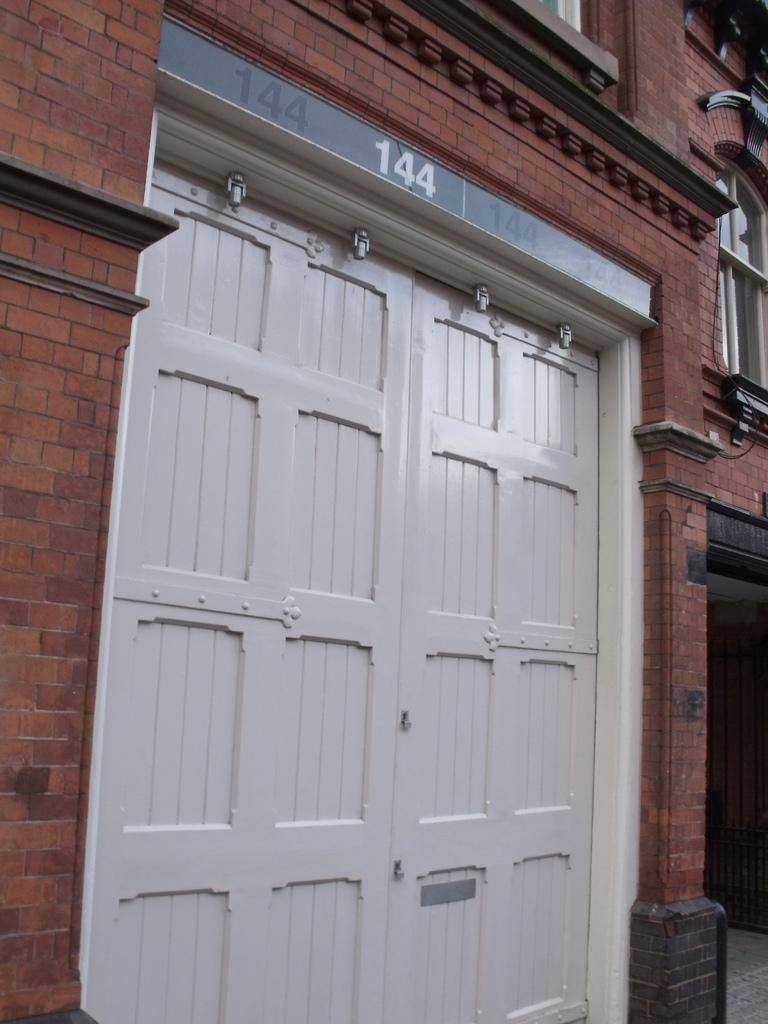Could you give a brief overview of what you see in this image? In this image, we can see a building with doors, glass window, brick wall. Right side of the image, we can see a grill, footpath. 